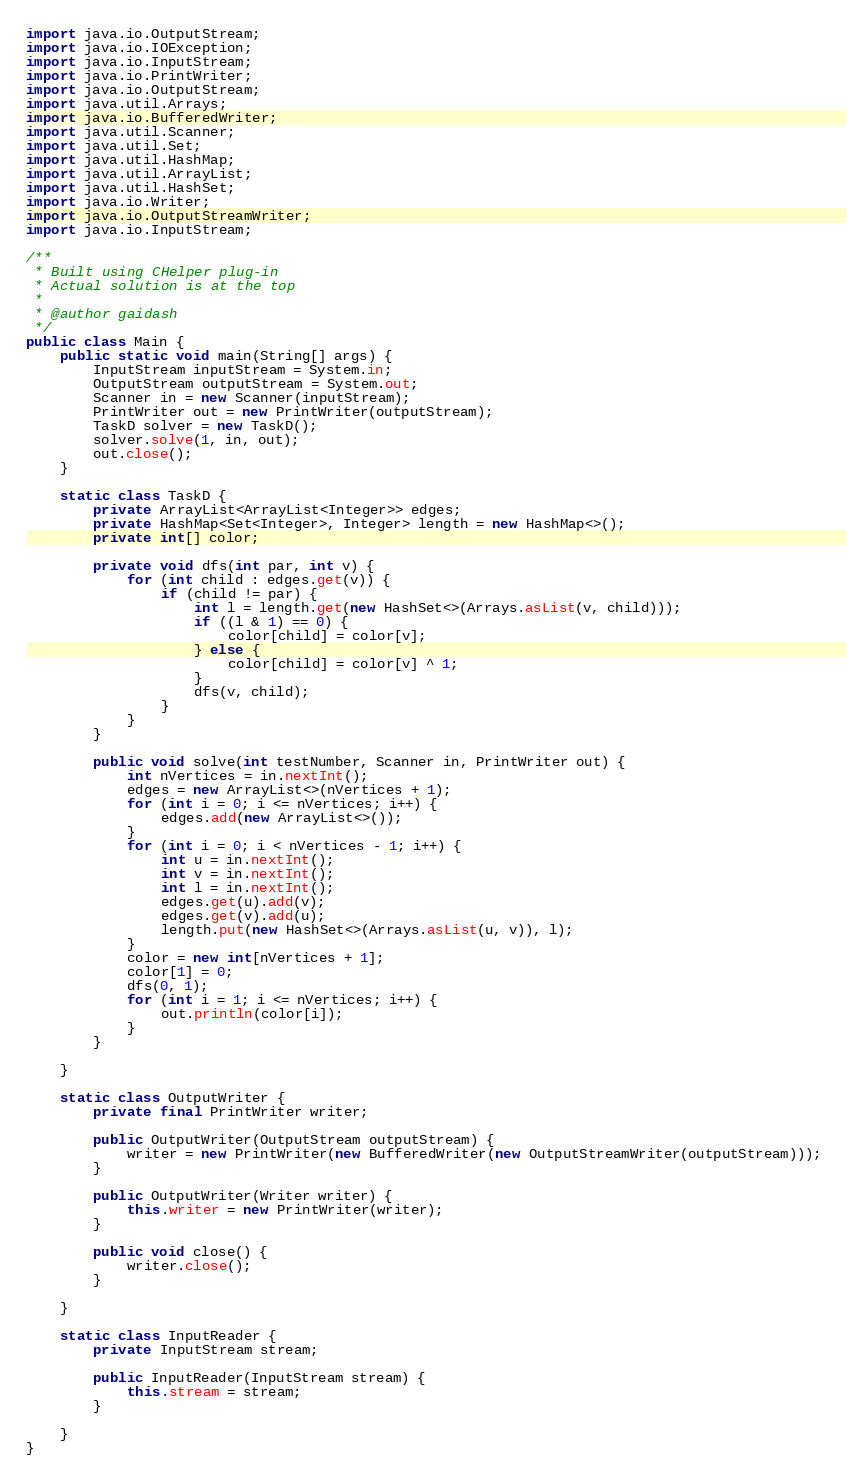Convert code to text. <code><loc_0><loc_0><loc_500><loc_500><_Java_>import java.io.OutputStream;
import java.io.IOException;
import java.io.InputStream;
import java.io.PrintWriter;
import java.io.OutputStream;
import java.util.Arrays;
import java.io.BufferedWriter;
import java.util.Scanner;
import java.util.Set;
import java.util.HashMap;
import java.util.ArrayList;
import java.util.HashSet;
import java.io.Writer;
import java.io.OutputStreamWriter;
import java.io.InputStream;

/**
 * Built using CHelper plug-in
 * Actual solution is at the top
 *
 * @author gaidash
 */
public class Main {
    public static void main(String[] args) {
        InputStream inputStream = System.in;
        OutputStream outputStream = System.out;
        Scanner in = new Scanner(inputStream);
        PrintWriter out = new PrintWriter(outputStream);
        TaskD solver = new TaskD();
        solver.solve(1, in, out);
        out.close();
    }

    static class TaskD {
        private ArrayList<ArrayList<Integer>> edges;
        private HashMap<Set<Integer>, Integer> length = new HashMap<>();
        private int[] color;

        private void dfs(int par, int v) {
            for (int child : edges.get(v)) {
                if (child != par) {
                    int l = length.get(new HashSet<>(Arrays.asList(v, child)));
                    if ((l & 1) == 0) {
                        color[child] = color[v];
                    } else {
                        color[child] = color[v] ^ 1;
                    }
                    dfs(v, child);
                }
            }
        }

        public void solve(int testNumber, Scanner in, PrintWriter out) {
            int nVertices = in.nextInt();
            edges = new ArrayList<>(nVertices + 1);
            for (int i = 0; i <= nVertices; i++) {
                edges.add(new ArrayList<>());
            }
            for (int i = 0; i < nVertices - 1; i++) {
                int u = in.nextInt();
                int v = in.nextInt();
                int l = in.nextInt();
                edges.get(u).add(v);
                edges.get(v).add(u);
                length.put(new HashSet<>(Arrays.asList(u, v)), l);
            }
            color = new int[nVertices + 1];
            color[1] = 0;
            dfs(0, 1);
            for (int i = 1; i <= nVertices; i++) {
                out.println(color[i]);
            }
        }

    }

    static class OutputWriter {
        private final PrintWriter writer;

        public OutputWriter(OutputStream outputStream) {
            writer = new PrintWriter(new BufferedWriter(new OutputStreamWriter(outputStream)));
        }

        public OutputWriter(Writer writer) {
            this.writer = new PrintWriter(writer);
        }

        public void close() {
            writer.close();
        }

    }

    static class InputReader {
        private InputStream stream;

        public InputReader(InputStream stream) {
            this.stream = stream;
        }

    }
}

</code> 